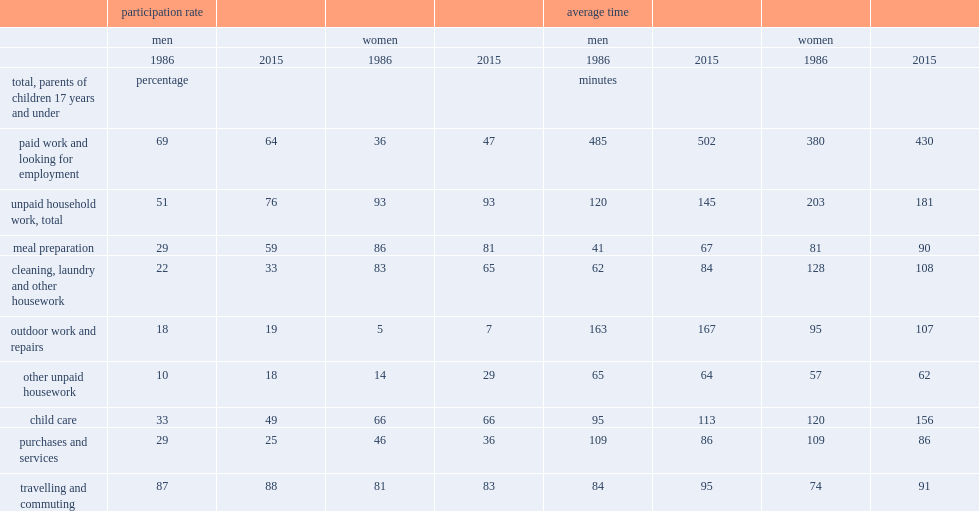What were the percentages of the participation rate of mothers in household work remained higher than that of fathers during the course of an average day in 2015. 93 76.0. What were the percentages of fathers' participation in household work in1986 and 2015 respectively. 51.0 76.0. How many hours had fathers spent when they had performed household work in 2015. 2.416667. How many hours had mothers spent when they had performed household work in 2015. 3.016667. 